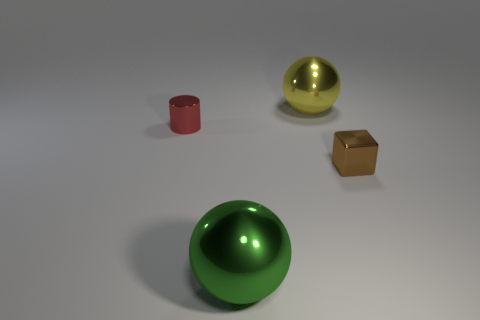Does the tiny metal block have the same color as the shiny object behind the shiny cylinder?
Provide a short and direct response. No. What is the color of the large metal sphere that is in front of the big object that is behind the small metal cube?
Your answer should be compact. Green. Are there any other things that are the same size as the brown block?
Offer a terse response. Yes. Do the small object that is left of the brown metal object and the small brown metallic thing have the same shape?
Your answer should be compact. No. How many things are on the right side of the small shiny cylinder and behind the tiny shiny block?
Offer a very short reply. 1. What is the color of the small metallic thing that is on the left side of the metal ball right of the shiny sphere that is in front of the large yellow thing?
Offer a terse response. Red. How many shiny balls are on the right side of the small shiny object to the left of the yellow metal sphere?
Keep it short and to the point. 2. What number of other things are there of the same shape as the small red object?
Give a very brief answer. 0. What number of things are large balls or metallic objects that are right of the big green metallic thing?
Provide a succinct answer. 3. Is the number of yellow things in front of the metallic block greater than the number of big yellow shiny spheres that are left of the big yellow object?
Make the answer very short. No. 